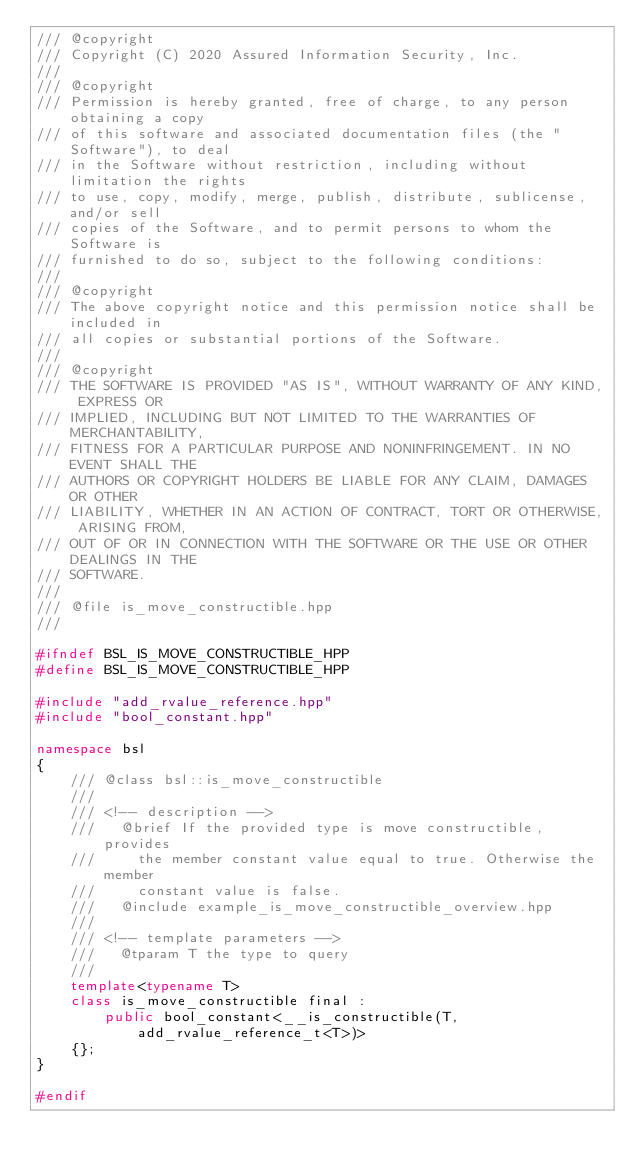Convert code to text. <code><loc_0><loc_0><loc_500><loc_500><_C++_>/// @copyright
/// Copyright (C) 2020 Assured Information Security, Inc.
///
/// @copyright
/// Permission is hereby granted, free of charge, to any person obtaining a copy
/// of this software and associated documentation files (the "Software"), to deal
/// in the Software without restriction, including without limitation the rights
/// to use, copy, modify, merge, publish, distribute, sublicense, and/or sell
/// copies of the Software, and to permit persons to whom the Software is
/// furnished to do so, subject to the following conditions:
///
/// @copyright
/// The above copyright notice and this permission notice shall be included in
/// all copies or substantial portions of the Software.
///
/// @copyright
/// THE SOFTWARE IS PROVIDED "AS IS", WITHOUT WARRANTY OF ANY KIND, EXPRESS OR
/// IMPLIED, INCLUDING BUT NOT LIMITED TO THE WARRANTIES OF MERCHANTABILITY,
/// FITNESS FOR A PARTICULAR PURPOSE AND NONINFRINGEMENT. IN NO EVENT SHALL THE
/// AUTHORS OR COPYRIGHT HOLDERS BE LIABLE FOR ANY CLAIM, DAMAGES OR OTHER
/// LIABILITY, WHETHER IN AN ACTION OF CONTRACT, TORT OR OTHERWISE, ARISING FROM,
/// OUT OF OR IN CONNECTION WITH THE SOFTWARE OR THE USE OR OTHER DEALINGS IN THE
/// SOFTWARE.
///
/// @file is_move_constructible.hpp
///

#ifndef BSL_IS_MOVE_CONSTRUCTIBLE_HPP
#define BSL_IS_MOVE_CONSTRUCTIBLE_HPP

#include "add_rvalue_reference.hpp"
#include "bool_constant.hpp"

namespace bsl
{
    /// @class bsl::is_move_constructible
    ///
    /// <!-- description -->
    ///   @brief If the provided type is move constructible, provides
    ///     the member constant value equal to true. Otherwise the member
    ///     constant value is false.
    ///   @include example_is_move_constructible_overview.hpp
    ///
    /// <!-- template parameters -->
    ///   @tparam T the type to query
    ///
    template<typename T>
    class is_move_constructible final :
        public bool_constant<__is_constructible(T, add_rvalue_reference_t<T>)>
    {};
}

#endif
</code> 